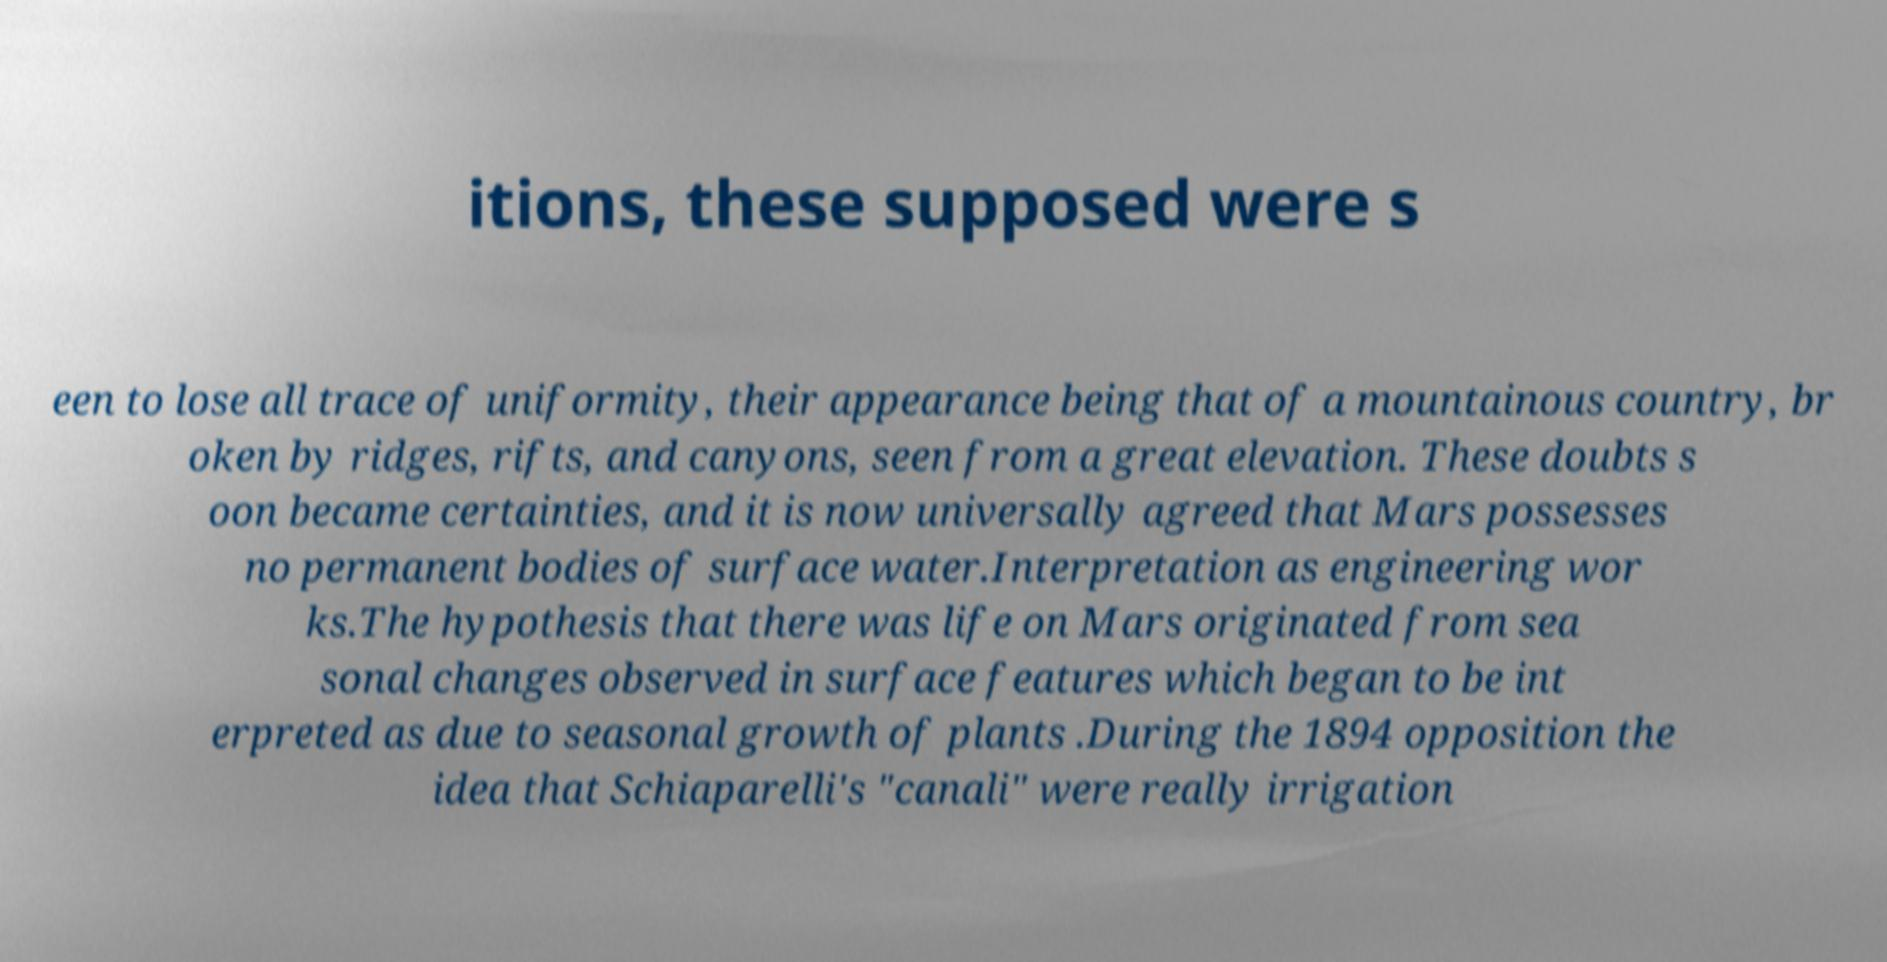Can you accurately transcribe the text from the provided image for me? itions, these supposed were s een to lose all trace of uniformity, their appearance being that of a mountainous country, br oken by ridges, rifts, and canyons, seen from a great elevation. These doubts s oon became certainties, and it is now universally agreed that Mars possesses no permanent bodies of surface water.Interpretation as engineering wor ks.The hypothesis that there was life on Mars originated from sea sonal changes observed in surface features which began to be int erpreted as due to seasonal growth of plants .During the 1894 opposition the idea that Schiaparelli's "canali" were really irrigation 